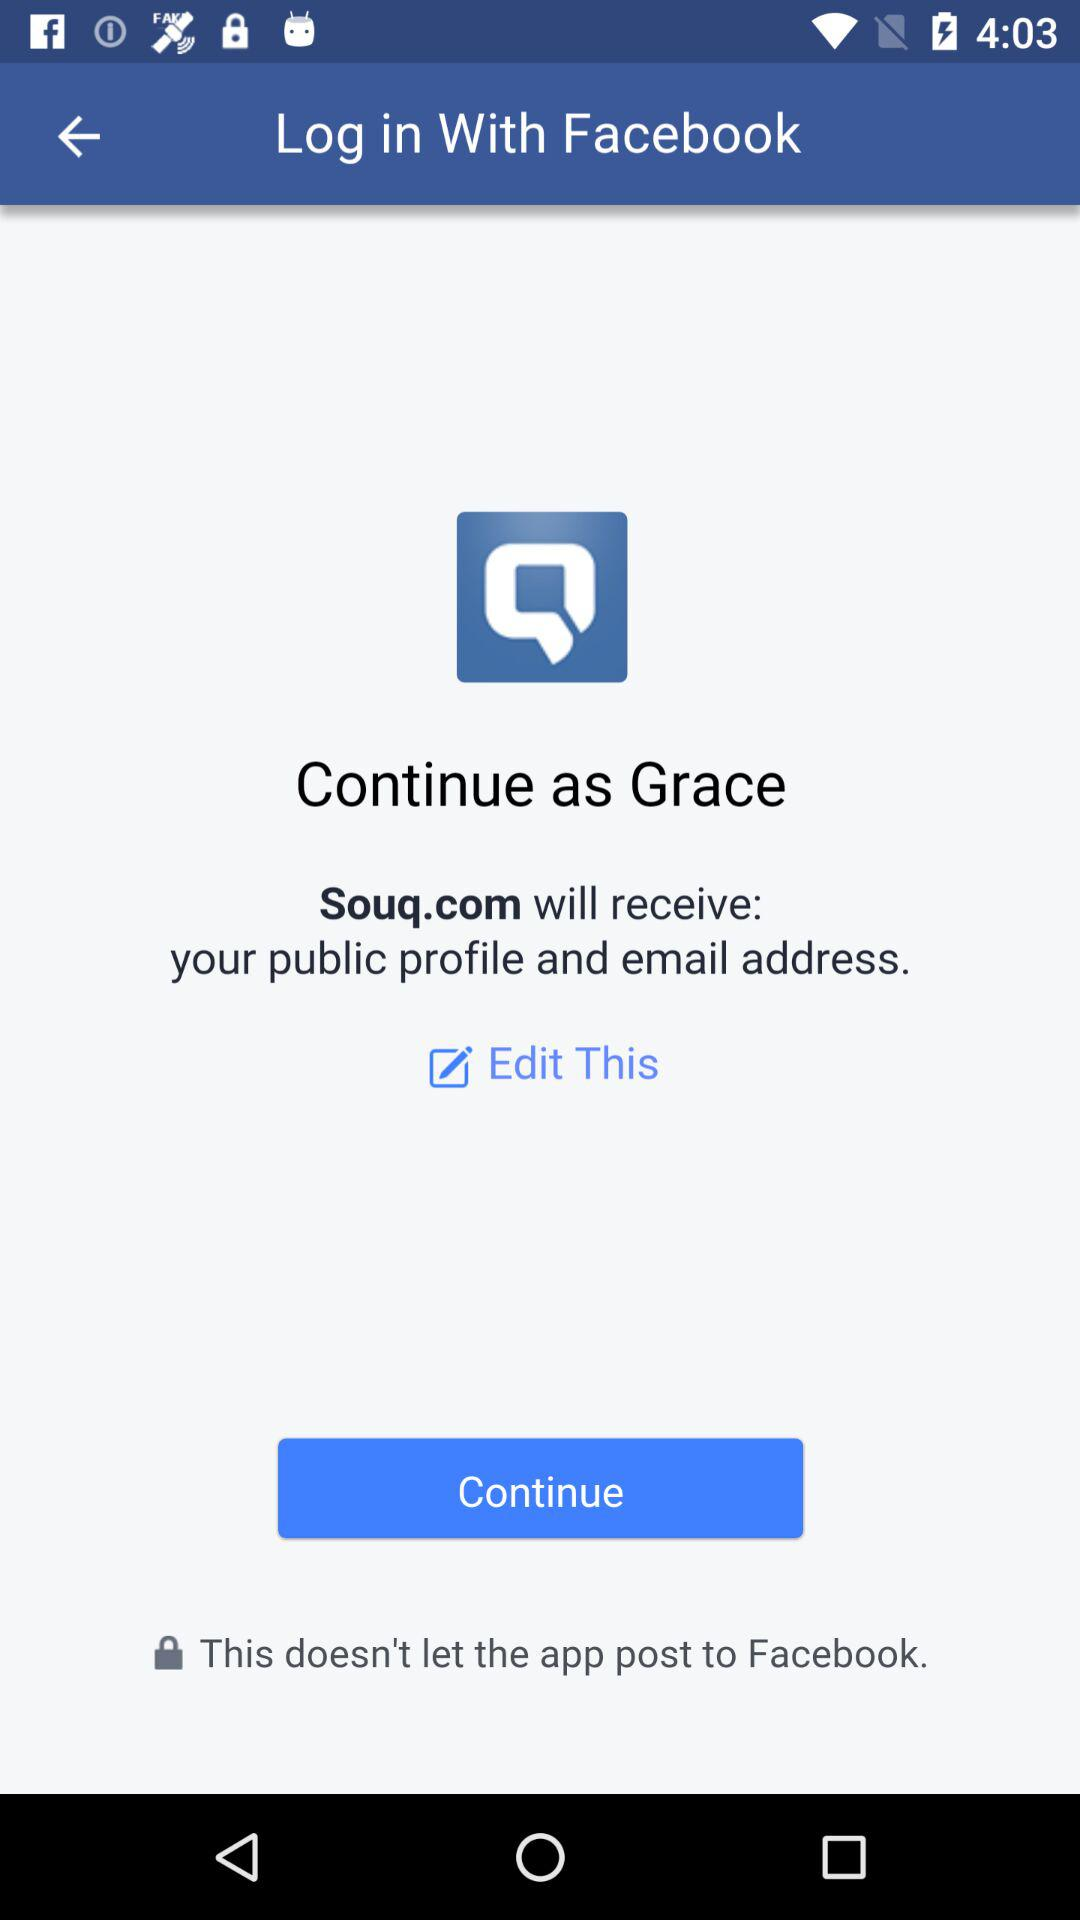What is the user name? The user name is Grace. 